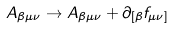<formula> <loc_0><loc_0><loc_500><loc_500>A _ { \beta \mu \nu } \rightarrow A _ { \beta \mu \nu } + \partial _ { [ \beta } f _ { \mu \nu ] }</formula> 